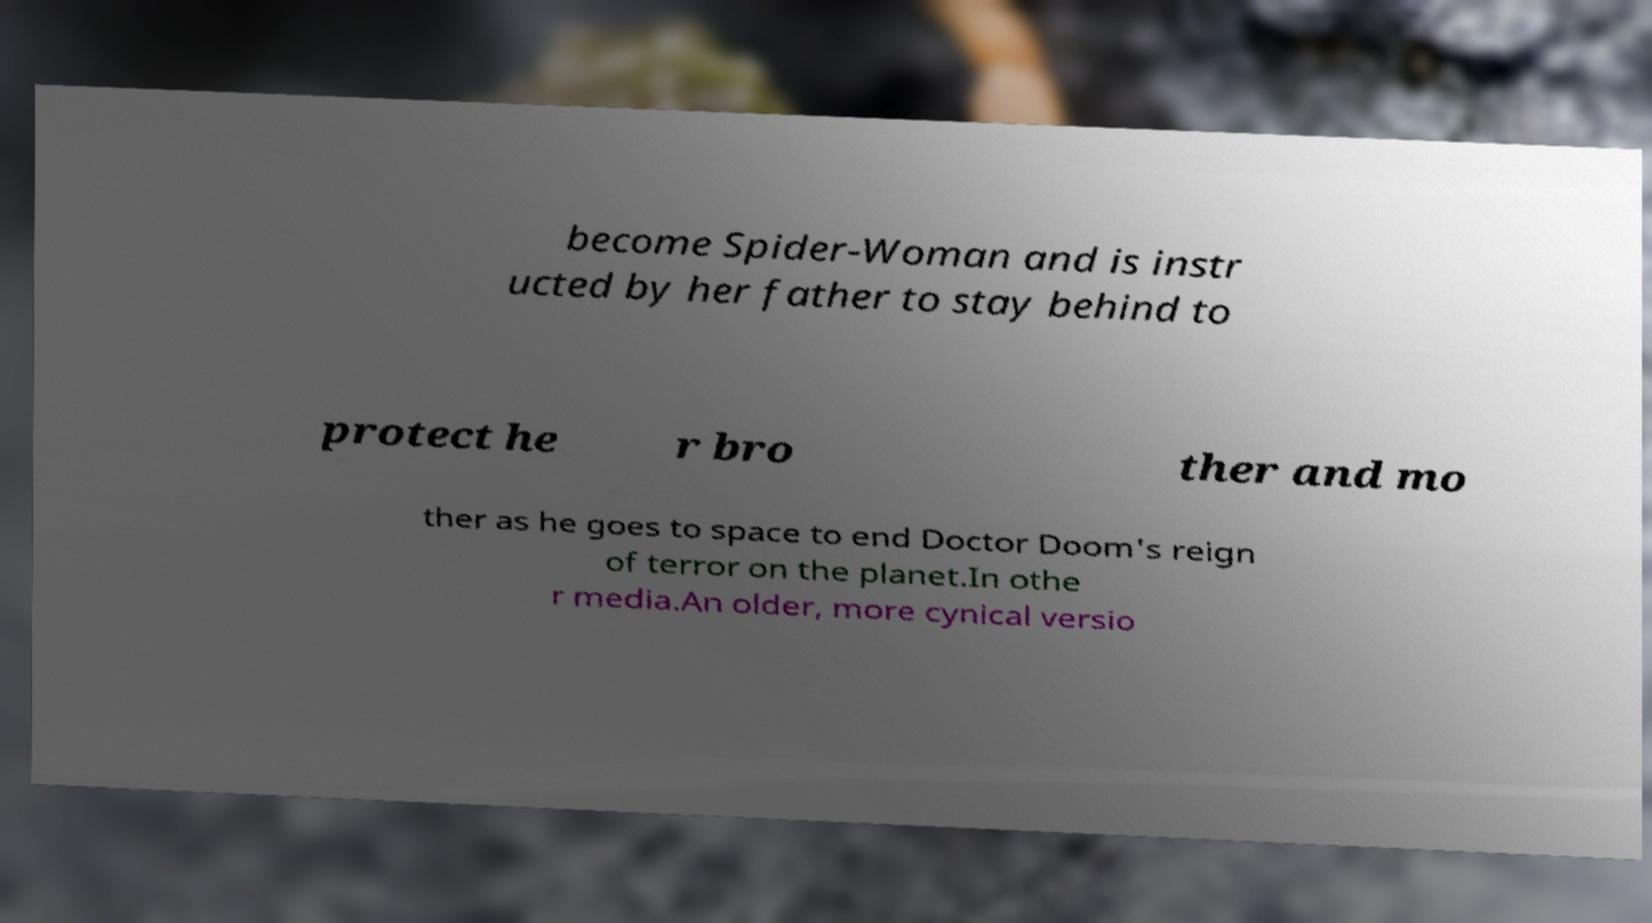For documentation purposes, I need the text within this image transcribed. Could you provide that? become Spider-Woman and is instr ucted by her father to stay behind to protect he r bro ther and mo ther as he goes to space to end Doctor Doom's reign of terror on the planet.In othe r media.An older, more cynical versio 